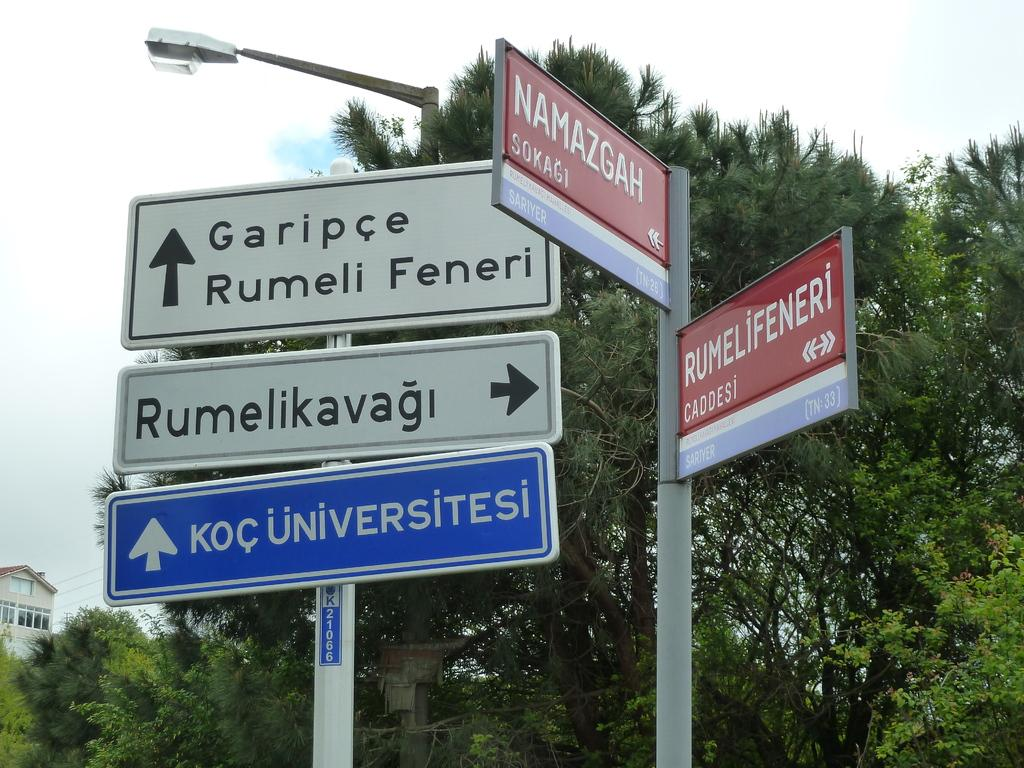<image>
Give a short and clear explanation of the subsequent image. Five different signs are pointing in different direction, to point people in the direction of different roads like Rumelikavagi and Namazgah. 